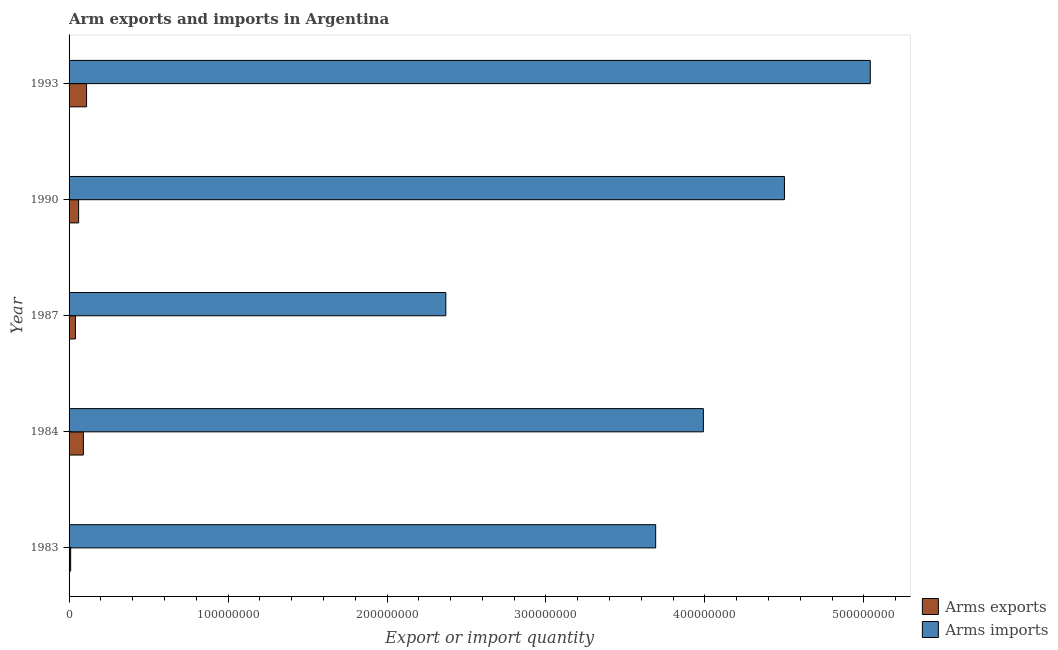How many different coloured bars are there?
Give a very brief answer. 2. How many groups of bars are there?
Give a very brief answer. 5. What is the arms exports in 1993?
Ensure brevity in your answer.  1.10e+07. Across all years, what is the maximum arms imports?
Provide a succinct answer. 5.04e+08. Across all years, what is the minimum arms exports?
Give a very brief answer. 1.00e+06. In which year was the arms imports maximum?
Your answer should be compact. 1993. In which year was the arms imports minimum?
Keep it short and to the point. 1987. What is the total arms imports in the graph?
Give a very brief answer. 1.96e+09. What is the difference between the arms exports in 1984 and that in 1987?
Keep it short and to the point. 5.00e+06. What is the difference between the arms imports in 1984 and the arms exports in 1987?
Offer a very short reply. 3.95e+08. What is the average arms exports per year?
Ensure brevity in your answer.  6.20e+06. In the year 1987, what is the difference between the arms imports and arms exports?
Your answer should be compact. 2.33e+08. What is the ratio of the arms exports in 1984 to that in 1990?
Offer a very short reply. 1.5. Is the arms imports in 1990 less than that in 1993?
Your answer should be compact. Yes. Is the difference between the arms imports in 1983 and 1990 greater than the difference between the arms exports in 1983 and 1990?
Make the answer very short. No. What is the difference between the highest and the second highest arms exports?
Make the answer very short. 2.00e+06. What is the difference between the highest and the lowest arms imports?
Provide a succinct answer. 2.67e+08. What does the 1st bar from the top in 1993 represents?
Provide a short and direct response. Arms imports. What does the 2nd bar from the bottom in 1984 represents?
Your answer should be very brief. Arms imports. How many bars are there?
Ensure brevity in your answer.  10. Are all the bars in the graph horizontal?
Your response must be concise. Yes. How many years are there in the graph?
Keep it short and to the point. 5. What is the difference between two consecutive major ticks on the X-axis?
Offer a very short reply. 1.00e+08. Does the graph contain any zero values?
Ensure brevity in your answer.  No. Where does the legend appear in the graph?
Offer a terse response. Bottom right. How many legend labels are there?
Your response must be concise. 2. What is the title of the graph?
Provide a succinct answer. Arm exports and imports in Argentina. Does "Agricultural land" appear as one of the legend labels in the graph?
Give a very brief answer. No. What is the label or title of the X-axis?
Your answer should be very brief. Export or import quantity. What is the label or title of the Y-axis?
Your answer should be compact. Year. What is the Export or import quantity in Arms imports in 1983?
Your answer should be compact. 3.69e+08. What is the Export or import quantity of Arms exports in 1984?
Keep it short and to the point. 9.00e+06. What is the Export or import quantity in Arms imports in 1984?
Make the answer very short. 3.99e+08. What is the Export or import quantity of Arms imports in 1987?
Make the answer very short. 2.37e+08. What is the Export or import quantity of Arms imports in 1990?
Your answer should be compact. 4.50e+08. What is the Export or import quantity in Arms exports in 1993?
Your answer should be compact. 1.10e+07. What is the Export or import quantity in Arms imports in 1993?
Offer a terse response. 5.04e+08. Across all years, what is the maximum Export or import quantity of Arms exports?
Make the answer very short. 1.10e+07. Across all years, what is the maximum Export or import quantity in Arms imports?
Make the answer very short. 5.04e+08. Across all years, what is the minimum Export or import quantity of Arms imports?
Give a very brief answer. 2.37e+08. What is the total Export or import quantity in Arms exports in the graph?
Your answer should be compact. 3.10e+07. What is the total Export or import quantity in Arms imports in the graph?
Your answer should be very brief. 1.96e+09. What is the difference between the Export or import quantity of Arms exports in 1983 and that in 1984?
Give a very brief answer. -8.00e+06. What is the difference between the Export or import quantity of Arms imports in 1983 and that in 1984?
Your answer should be very brief. -3.00e+07. What is the difference between the Export or import quantity of Arms exports in 1983 and that in 1987?
Make the answer very short. -3.00e+06. What is the difference between the Export or import quantity in Arms imports in 1983 and that in 1987?
Your response must be concise. 1.32e+08. What is the difference between the Export or import quantity of Arms exports in 1983 and that in 1990?
Provide a short and direct response. -5.00e+06. What is the difference between the Export or import quantity of Arms imports in 1983 and that in 1990?
Keep it short and to the point. -8.10e+07. What is the difference between the Export or import quantity in Arms exports in 1983 and that in 1993?
Offer a very short reply. -1.00e+07. What is the difference between the Export or import quantity in Arms imports in 1983 and that in 1993?
Give a very brief answer. -1.35e+08. What is the difference between the Export or import quantity in Arms imports in 1984 and that in 1987?
Your response must be concise. 1.62e+08. What is the difference between the Export or import quantity in Arms imports in 1984 and that in 1990?
Your answer should be compact. -5.10e+07. What is the difference between the Export or import quantity of Arms exports in 1984 and that in 1993?
Offer a terse response. -2.00e+06. What is the difference between the Export or import quantity in Arms imports in 1984 and that in 1993?
Keep it short and to the point. -1.05e+08. What is the difference between the Export or import quantity of Arms exports in 1987 and that in 1990?
Your answer should be compact. -2.00e+06. What is the difference between the Export or import quantity of Arms imports in 1987 and that in 1990?
Keep it short and to the point. -2.13e+08. What is the difference between the Export or import quantity of Arms exports in 1987 and that in 1993?
Your response must be concise. -7.00e+06. What is the difference between the Export or import quantity in Arms imports in 1987 and that in 1993?
Your answer should be compact. -2.67e+08. What is the difference between the Export or import quantity of Arms exports in 1990 and that in 1993?
Make the answer very short. -5.00e+06. What is the difference between the Export or import quantity in Arms imports in 1990 and that in 1993?
Keep it short and to the point. -5.40e+07. What is the difference between the Export or import quantity of Arms exports in 1983 and the Export or import quantity of Arms imports in 1984?
Offer a very short reply. -3.98e+08. What is the difference between the Export or import quantity in Arms exports in 1983 and the Export or import quantity in Arms imports in 1987?
Give a very brief answer. -2.36e+08. What is the difference between the Export or import quantity in Arms exports in 1983 and the Export or import quantity in Arms imports in 1990?
Give a very brief answer. -4.49e+08. What is the difference between the Export or import quantity of Arms exports in 1983 and the Export or import quantity of Arms imports in 1993?
Ensure brevity in your answer.  -5.03e+08. What is the difference between the Export or import quantity in Arms exports in 1984 and the Export or import quantity in Arms imports in 1987?
Give a very brief answer. -2.28e+08. What is the difference between the Export or import quantity in Arms exports in 1984 and the Export or import quantity in Arms imports in 1990?
Give a very brief answer. -4.41e+08. What is the difference between the Export or import quantity of Arms exports in 1984 and the Export or import quantity of Arms imports in 1993?
Offer a terse response. -4.95e+08. What is the difference between the Export or import quantity of Arms exports in 1987 and the Export or import quantity of Arms imports in 1990?
Keep it short and to the point. -4.46e+08. What is the difference between the Export or import quantity in Arms exports in 1987 and the Export or import quantity in Arms imports in 1993?
Provide a succinct answer. -5.00e+08. What is the difference between the Export or import quantity in Arms exports in 1990 and the Export or import quantity in Arms imports in 1993?
Ensure brevity in your answer.  -4.98e+08. What is the average Export or import quantity in Arms exports per year?
Keep it short and to the point. 6.20e+06. What is the average Export or import quantity of Arms imports per year?
Your answer should be very brief. 3.92e+08. In the year 1983, what is the difference between the Export or import quantity in Arms exports and Export or import quantity in Arms imports?
Provide a succinct answer. -3.68e+08. In the year 1984, what is the difference between the Export or import quantity in Arms exports and Export or import quantity in Arms imports?
Your answer should be very brief. -3.90e+08. In the year 1987, what is the difference between the Export or import quantity in Arms exports and Export or import quantity in Arms imports?
Provide a succinct answer. -2.33e+08. In the year 1990, what is the difference between the Export or import quantity in Arms exports and Export or import quantity in Arms imports?
Provide a succinct answer. -4.44e+08. In the year 1993, what is the difference between the Export or import quantity of Arms exports and Export or import quantity of Arms imports?
Offer a very short reply. -4.93e+08. What is the ratio of the Export or import quantity of Arms imports in 1983 to that in 1984?
Keep it short and to the point. 0.92. What is the ratio of the Export or import quantity of Arms imports in 1983 to that in 1987?
Provide a succinct answer. 1.56. What is the ratio of the Export or import quantity of Arms imports in 1983 to that in 1990?
Give a very brief answer. 0.82. What is the ratio of the Export or import quantity of Arms exports in 1983 to that in 1993?
Keep it short and to the point. 0.09. What is the ratio of the Export or import quantity in Arms imports in 1983 to that in 1993?
Provide a short and direct response. 0.73. What is the ratio of the Export or import quantity in Arms exports in 1984 to that in 1987?
Give a very brief answer. 2.25. What is the ratio of the Export or import quantity of Arms imports in 1984 to that in 1987?
Keep it short and to the point. 1.68. What is the ratio of the Export or import quantity in Arms exports in 1984 to that in 1990?
Keep it short and to the point. 1.5. What is the ratio of the Export or import quantity in Arms imports in 1984 to that in 1990?
Offer a terse response. 0.89. What is the ratio of the Export or import quantity of Arms exports in 1984 to that in 1993?
Make the answer very short. 0.82. What is the ratio of the Export or import quantity in Arms imports in 1984 to that in 1993?
Give a very brief answer. 0.79. What is the ratio of the Export or import quantity in Arms exports in 1987 to that in 1990?
Provide a succinct answer. 0.67. What is the ratio of the Export or import quantity of Arms imports in 1987 to that in 1990?
Your response must be concise. 0.53. What is the ratio of the Export or import quantity of Arms exports in 1987 to that in 1993?
Offer a very short reply. 0.36. What is the ratio of the Export or import quantity in Arms imports in 1987 to that in 1993?
Offer a terse response. 0.47. What is the ratio of the Export or import quantity in Arms exports in 1990 to that in 1993?
Make the answer very short. 0.55. What is the ratio of the Export or import quantity in Arms imports in 1990 to that in 1993?
Make the answer very short. 0.89. What is the difference between the highest and the second highest Export or import quantity in Arms imports?
Your response must be concise. 5.40e+07. What is the difference between the highest and the lowest Export or import quantity of Arms exports?
Your answer should be compact. 1.00e+07. What is the difference between the highest and the lowest Export or import quantity in Arms imports?
Make the answer very short. 2.67e+08. 